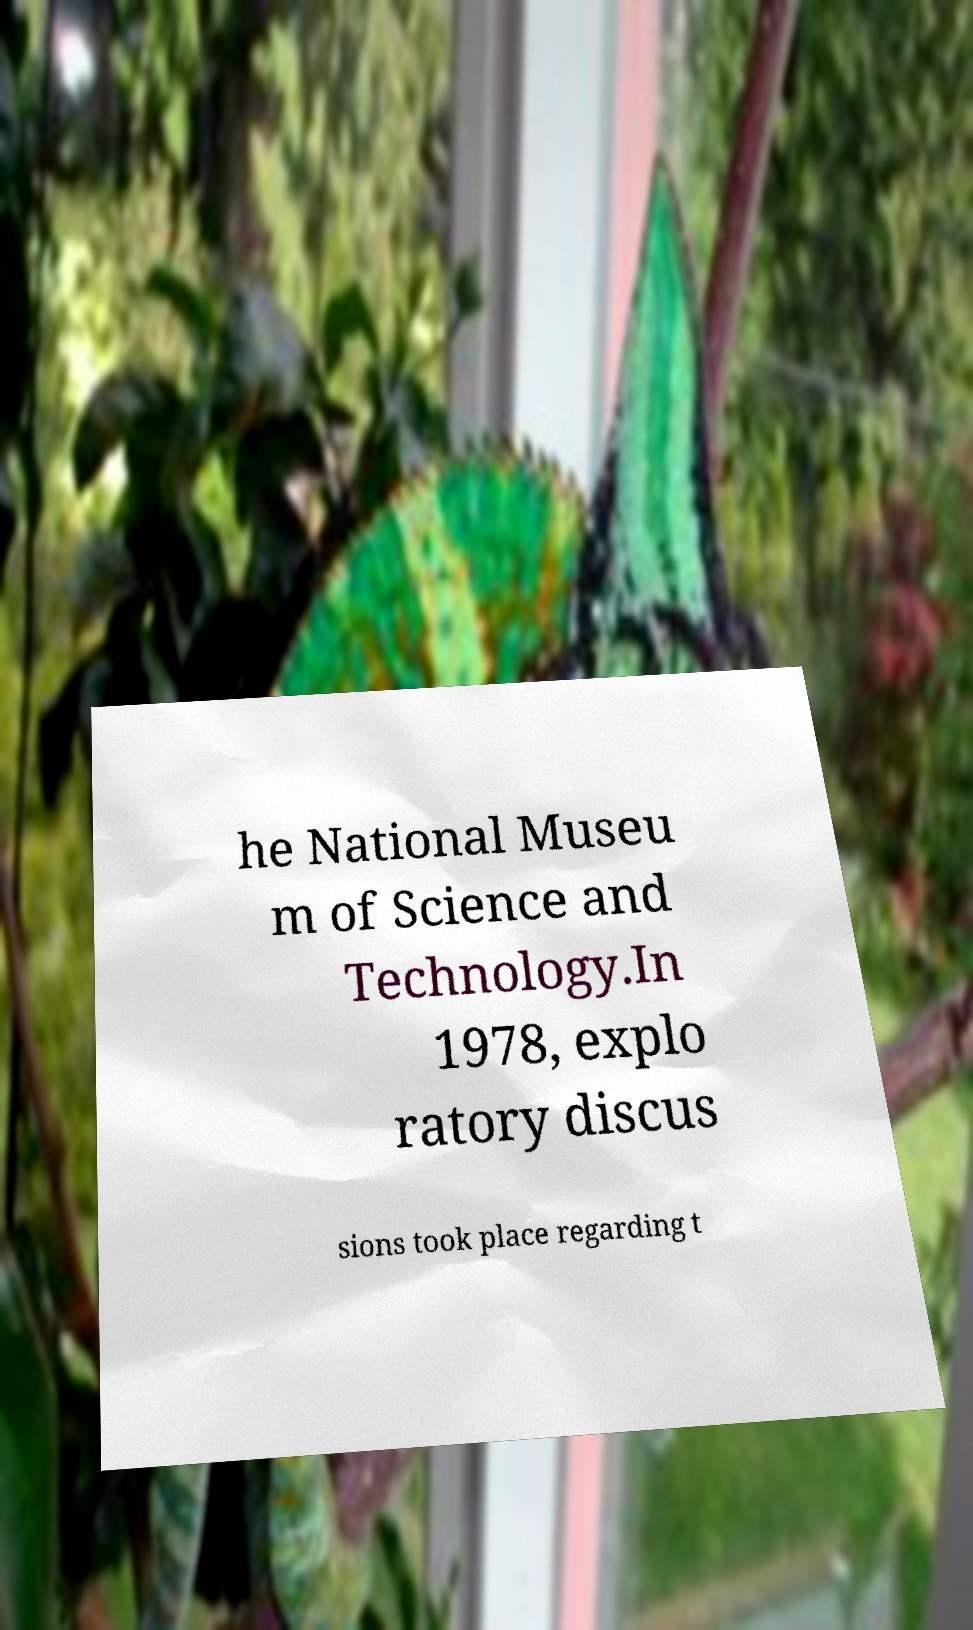I need the written content from this picture converted into text. Can you do that? he National Museu m of Science and Technology.In 1978, explo ratory discus sions took place regarding t 